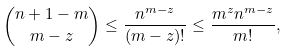Convert formula to latex. <formula><loc_0><loc_0><loc_500><loc_500>\binom { n + 1 - m } { m - z } \leq \frac { n ^ { m - z } } { ( m - z ) ! } \leq \frac { m ^ { z } n ^ { m - z } } { m ! } ,</formula> 